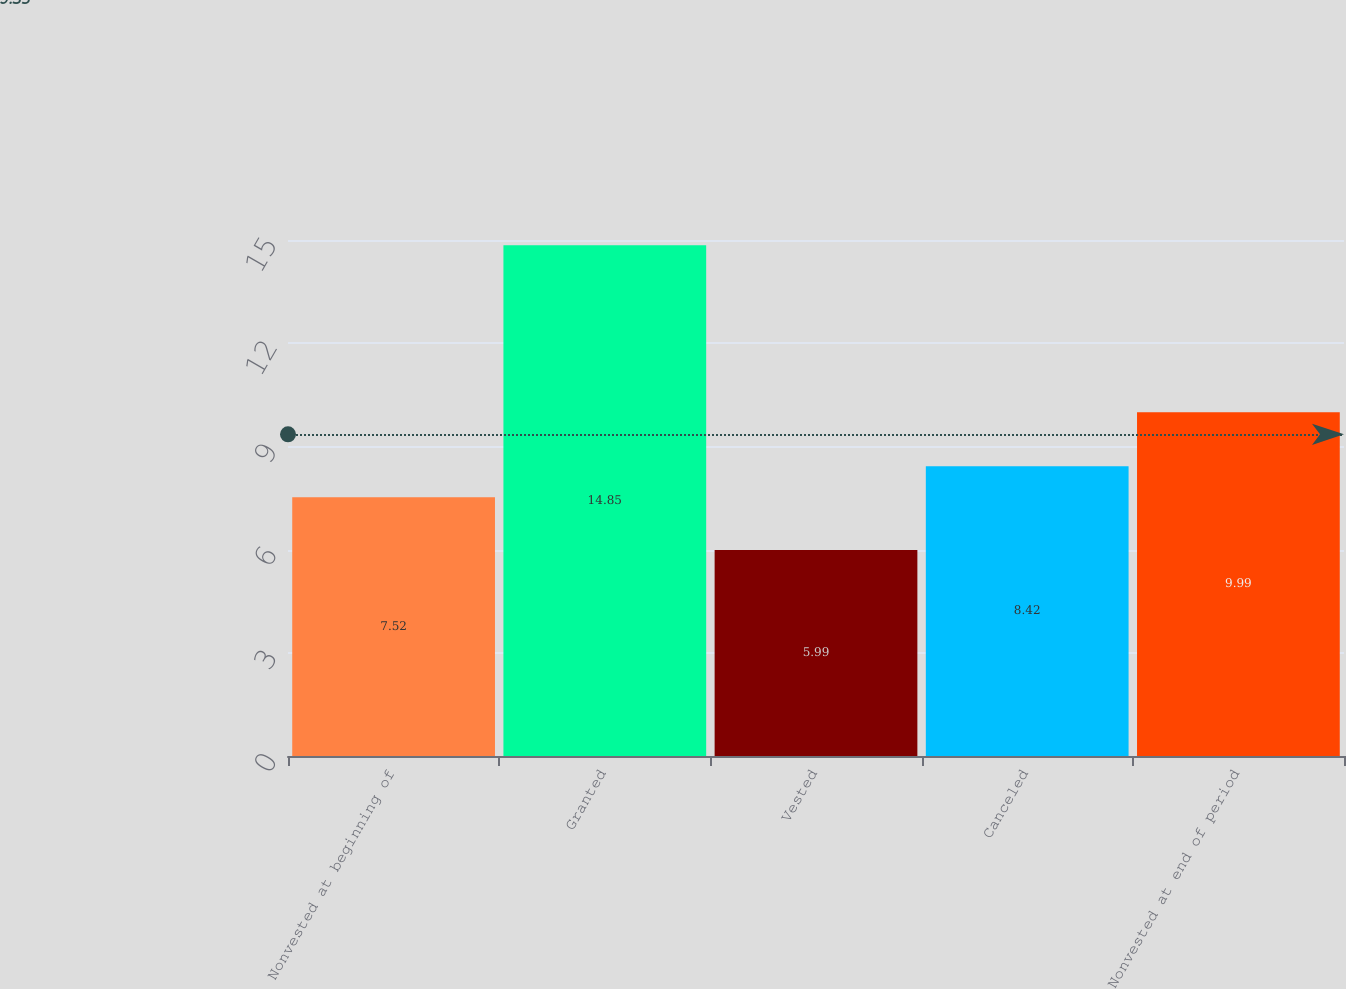Convert chart to OTSL. <chart><loc_0><loc_0><loc_500><loc_500><bar_chart><fcel>Nonvested at beginning of<fcel>Granted<fcel>Vested<fcel>Canceled<fcel>Nonvested at end of period<nl><fcel>7.52<fcel>14.85<fcel>5.99<fcel>8.42<fcel>9.99<nl></chart> 